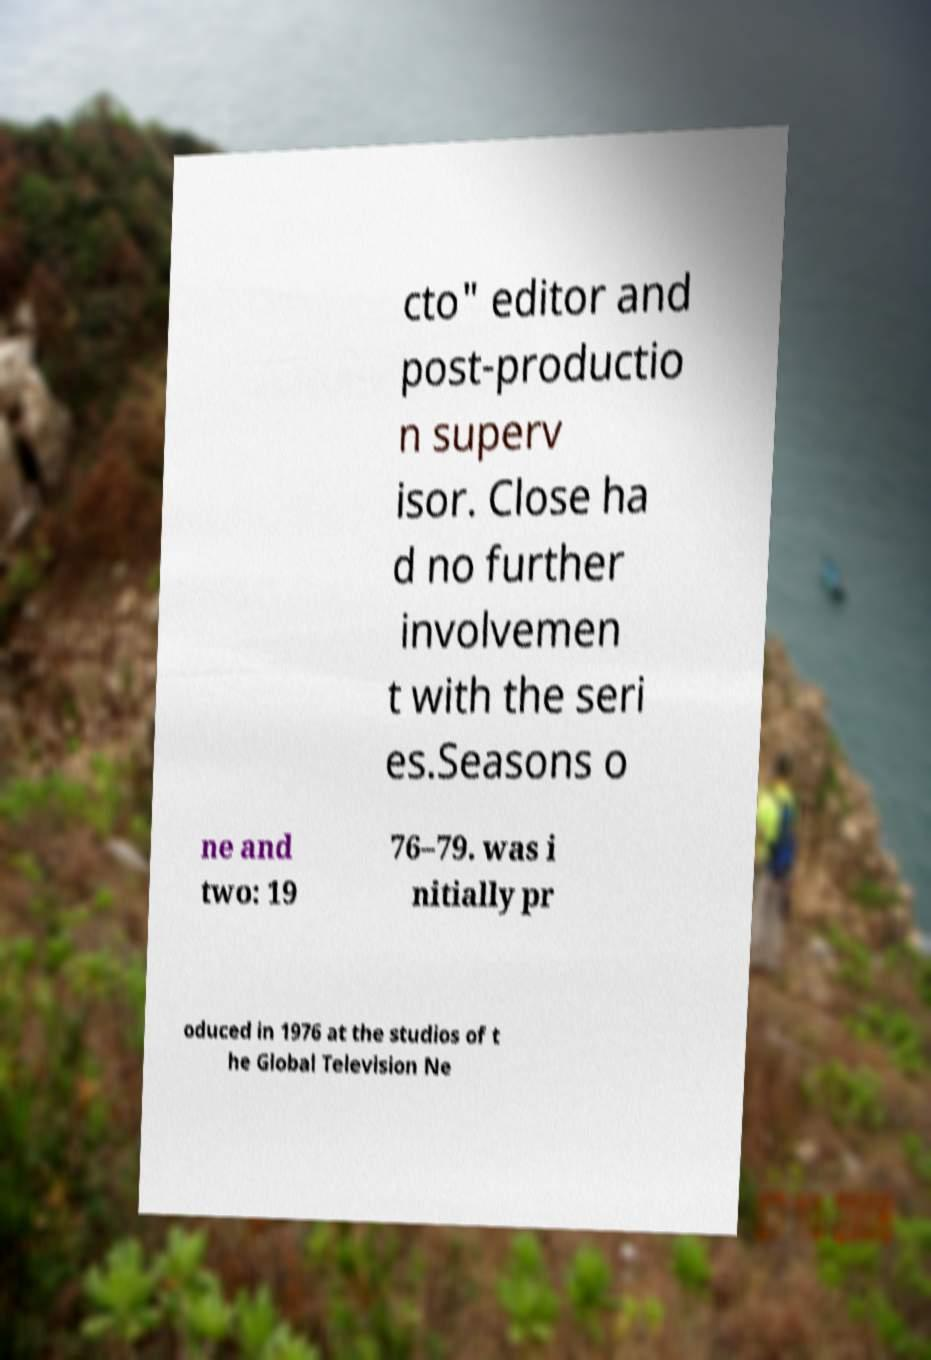For documentation purposes, I need the text within this image transcribed. Could you provide that? cto" editor and post-productio n superv isor. Close ha d no further involvemen t with the seri es.Seasons o ne and two: 19 76–79. was i nitially pr oduced in 1976 at the studios of t he Global Television Ne 